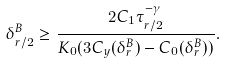<formula> <loc_0><loc_0><loc_500><loc_500>\delta ^ { B } _ { r / 2 } \geq \frac { 2 C _ { 1 } \tau _ { r / 2 } ^ { - \gamma } } { { K _ { 0 } } ( 3 C _ { y } ( \delta ^ { B } _ { r } ) - C _ { 0 } ( \delta ^ { B } _ { r } ) ) } .</formula> 